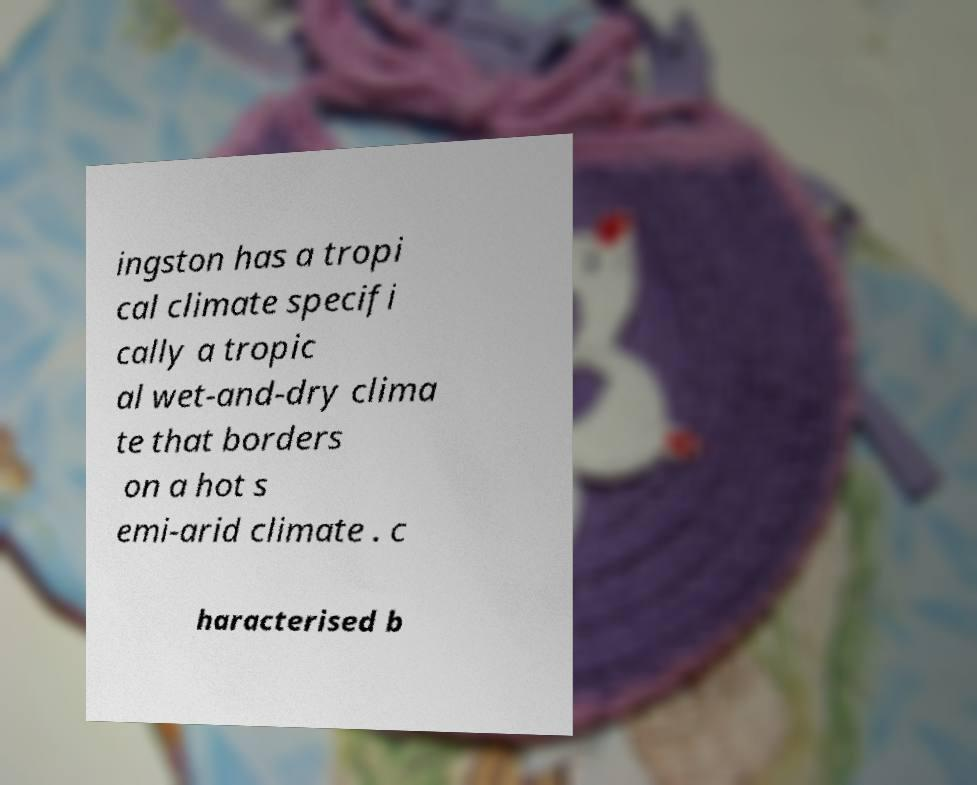What messages or text are displayed in this image? I need them in a readable, typed format. ingston has a tropi cal climate specifi cally a tropic al wet-and-dry clima te that borders on a hot s emi-arid climate . c haracterised b 